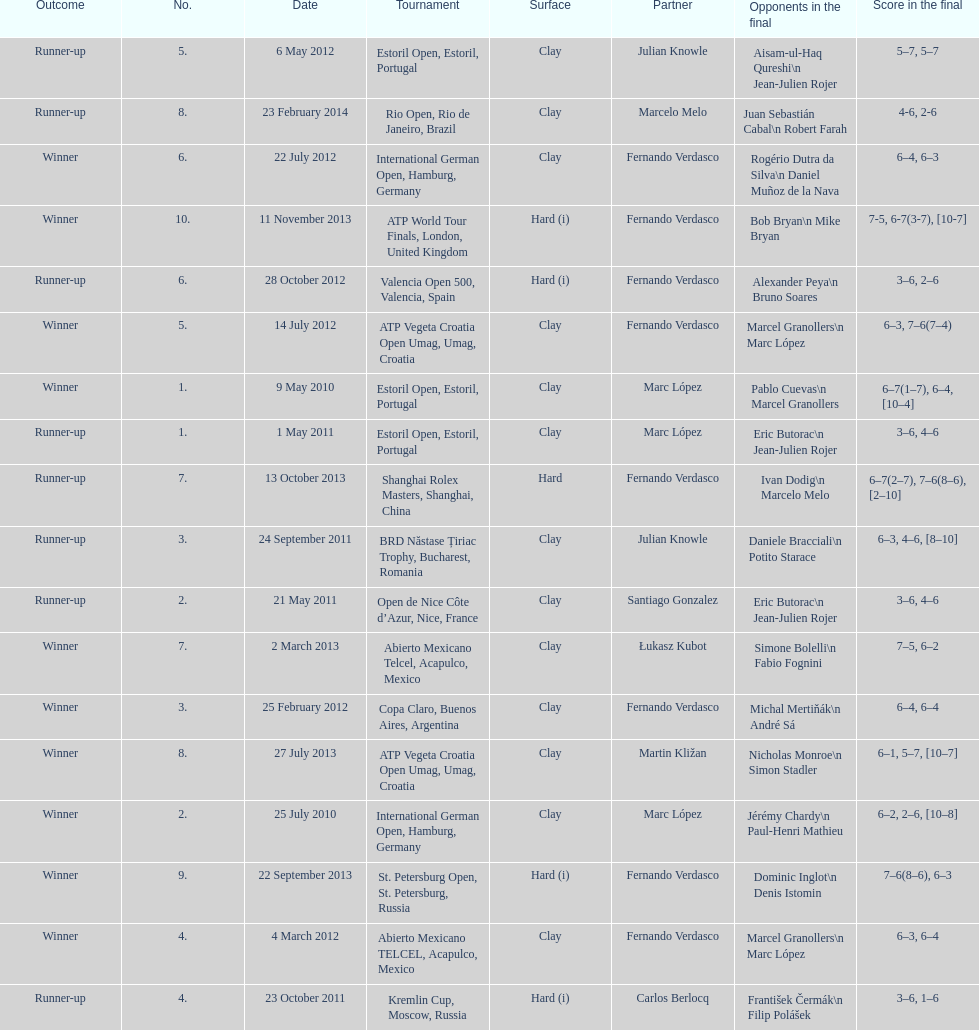How many partners from spain are listed? 2. 